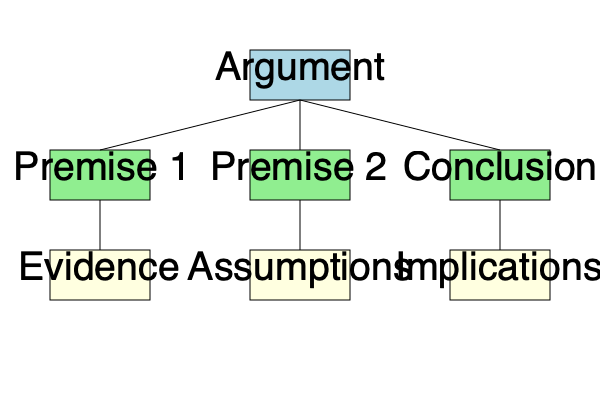Analyze the concept map above, which represents the structure of an argument. Which component of the argument would a rationalist be most likely to scrutinize first to evaluate the argument's logical validity? To answer this question, let's consider the approach a rationalist would take:

1. A rationalist prioritizes logical reasoning and empirical evidence.

2. The concept map shows the following components of an argument:
   - Premises (1 and 2)
   - Conclusion
   - Evidence
   - Assumptions
   - Implications

3. To evaluate logical validity, a rationalist would focus on the relationship between premises and conclusion.

4. However, before examining this relationship, a rationalist would want to ensure the premises themselves are sound.

5. The "Assumptions" component is crucial here, as it represents the underlying beliefs or suppositions that support the premises.

6. Unstated or faulty assumptions can undermine an entire argument, even if the logic connecting premises to conclusion is valid.

7. Therefore, a rationalist would likely begin by examining the assumptions to ensure they are justified and well-founded.

8. Only after validating the assumptions would a rationalist proceed to analyze the logical structure of the argument and its supporting evidence.

Given this reasoning, a rationalist would most likely scrutinize the "Assumptions" component first to evaluate the argument's logical validity.
Answer: Assumptions 